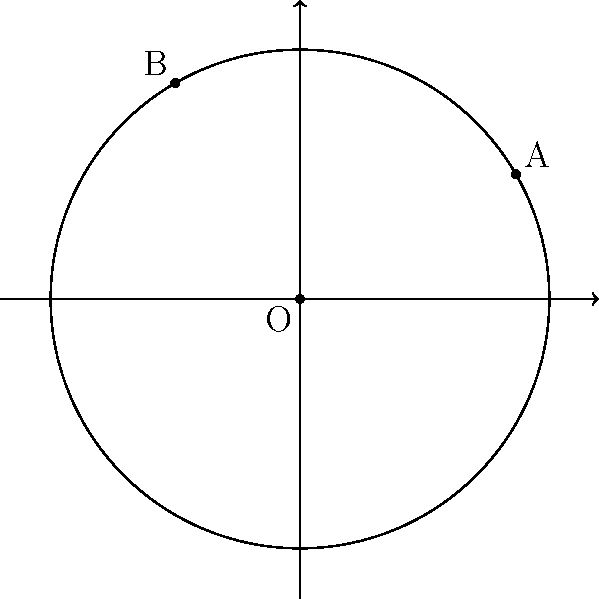You've discovered that your great-great-grandparents were born in two different towns in Victorian England. Using polar coordinates, their birthplaces are represented as points A and B on a map, where O is London. Point A has coordinates $(5, \frac{\pi}{6})$ and point B has coordinates $(5, \frac{2\pi}{3})$, with distances measured in hundreds of kilometers. Calculate the distance between these two ancestral birthplaces to the nearest kilometer. To find the distance between two points in polar coordinates, we can use the following steps:

1) First, recall the formula for the distance $d$ between two points $(r_1, \theta_1)$ and $(r_2, \theta_2)$ in polar coordinates:

   $$d = \sqrt{r_1^2 + r_2^2 - 2r_1r_2 \cos(\theta_2 - \theta_1)}$$

2) In this case, $r_1 = r_2 = 5$ (as both points are 5 hundred kilometers from London), $\theta_1 = \frac{\pi}{6}$, and $\theta_2 = \frac{2\pi}{3}$.

3) Substituting these values into the formula:

   $$d = \sqrt{5^2 + 5^2 - 2(5)(5) \cos(\frac{2\pi}{3} - \frac{\pi}{6})}$$

4) Simplify inside the parentheses:

   $$d = \sqrt{25 + 25 - 50 \cos(\frac{\pi}{2})}$$

5) Recall that $\cos(\frac{\pi}{2}) = 0$:

   $$d = \sqrt{25 + 25 - 50(0)} = \sqrt{50}$$

6) Simplify:

   $$d = 5\sqrt{2}$$

7) Convert to kilometers (remember, the original units were in hundreds of kilometers):

   $$d = 500\sqrt{2} \approx 707.11 \text{ km}$$

8) Rounding to the nearest kilometer:

   $$d \approx 707 \text{ km}$$
Answer: 707 km 